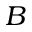<formula> <loc_0><loc_0><loc_500><loc_500>B</formula> 